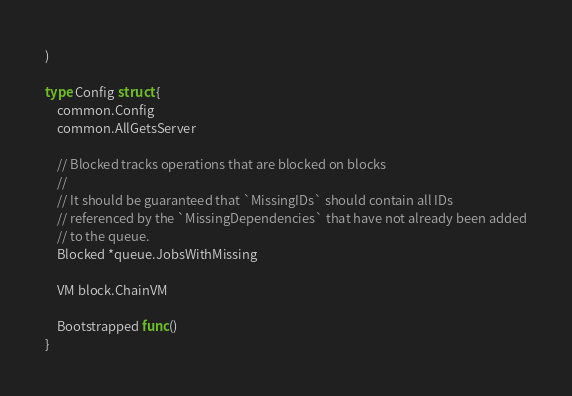Convert code to text. <code><loc_0><loc_0><loc_500><loc_500><_Go_>)

type Config struct {
	common.Config
	common.AllGetsServer

	// Blocked tracks operations that are blocked on blocks
	//
	// It should be guaranteed that `MissingIDs` should contain all IDs
	// referenced by the `MissingDependencies` that have not already been added
	// to the queue.
	Blocked *queue.JobsWithMissing

	VM block.ChainVM

	Bootstrapped func()
}
</code> 